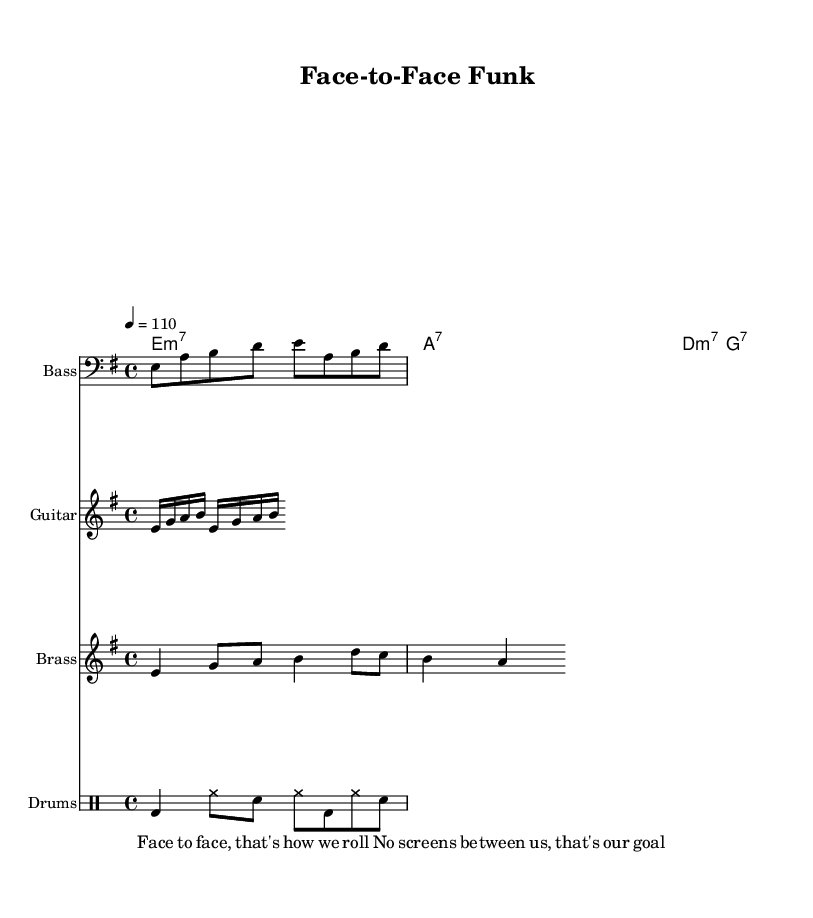What is the key signature of this music? The key signature is E minor, which is indicated by one sharp (F#).
Answer: E minor What is the time signature of the piece? The time signature is 4/4, which means there are four beats in each measure.
Answer: 4/4 What is the tempo marking? The tempo marking indicates a speed of 110 beats per minute, shown by the tempo marking in the score.
Answer: 110 How many beats does the bass line last for? The bass line consists of eight eighth notes and is combined with whole notes, giving a total of four measures of four beats each, making it 16 beats in total.
Answer: 16 What is the chord progression used in this piece? The chord progression consists of minor and seventh chords: E minor 7, A7, D minor 7, and G7, which form a repetitive groove that is characteristic of funk music.
Answer: E minor 7, A7, D minor 7, G7 What type of instrument is used for the riff? The riff is played by the guitar, as denoted by the staff heading "Guitar."
Answer: Guitar What aspect of customer interaction is emphasized in the lyrics? The lyrics emphasize the value of face-to-face interaction without screens, highlighting a preference for personal communication.
Answer: Face-to-face interaction 